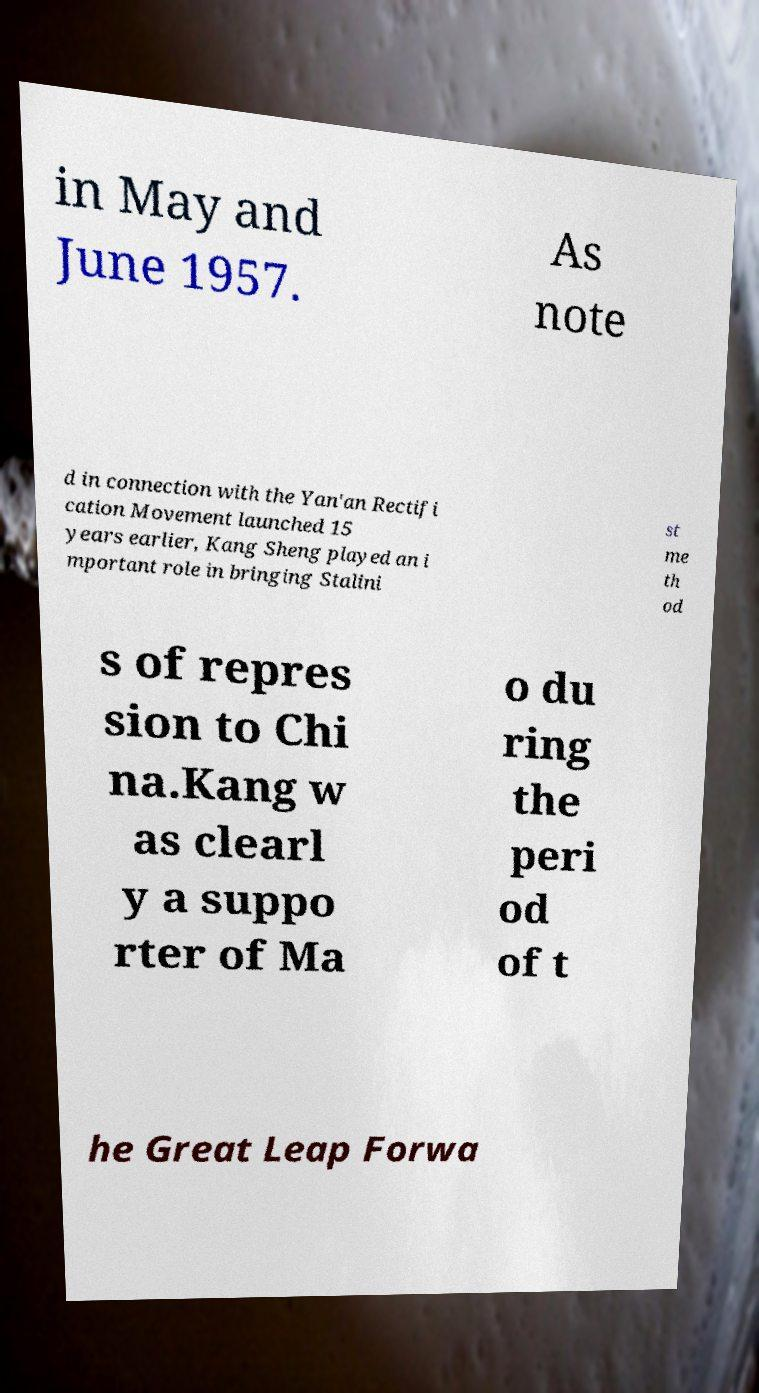Could you assist in decoding the text presented in this image and type it out clearly? in May and June 1957. As note d in connection with the Yan'an Rectifi cation Movement launched 15 years earlier, Kang Sheng played an i mportant role in bringing Stalini st me th od s of repres sion to Chi na.Kang w as clearl y a suppo rter of Ma o du ring the peri od of t he Great Leap Forwa 